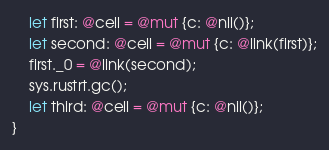<code> <loc_0><loc_0><loc_500><loc_500><_Rust_>    let first: @cell = @mut {c: @nil()};
    let second: @cell = @mut {c: @link(first)};
    first._0 = @link(second);
    sys.rustrt.gc();
    let third: @cell = @mut {c: @nil()};
}
</code> 